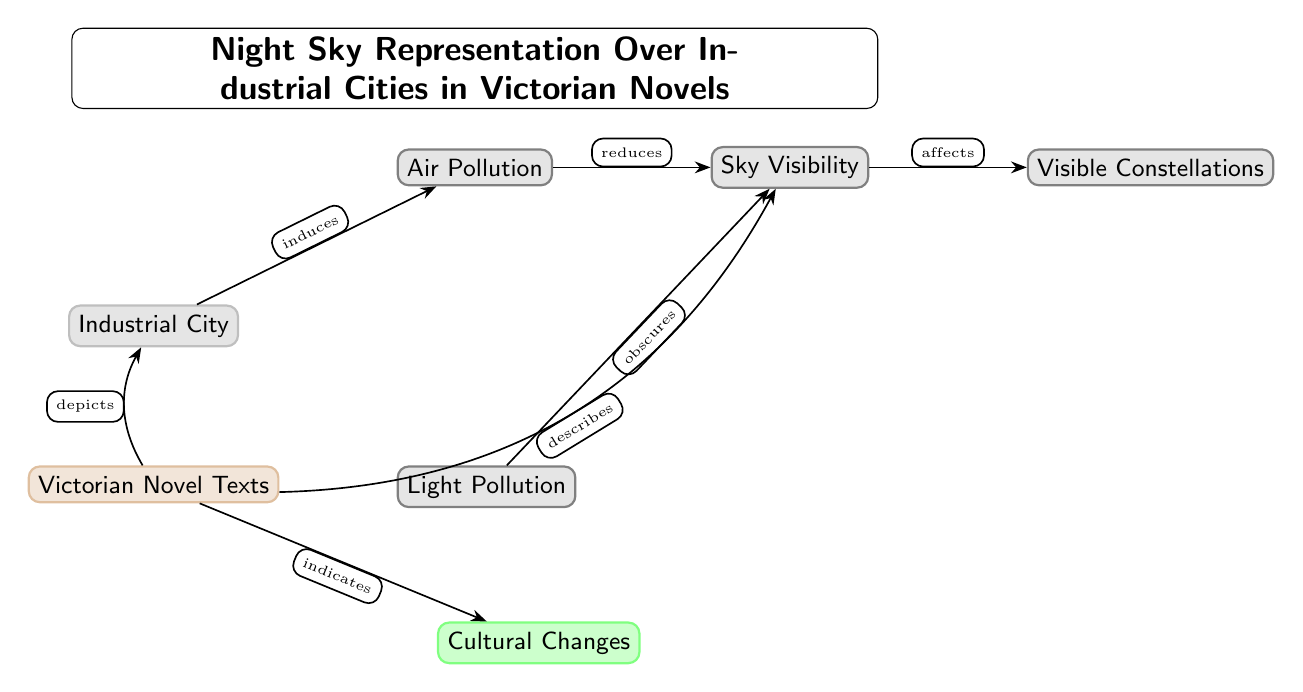What is the main depiction of the Victorian novels in the diagram? The main depiction of Victorian novels in the diagram is represented by the node labeled "Victorian Novel Texts". It is connected to the "Industrial City", indicating that the novels depict the industrial settings.
Answer: Victorian Novel Texts How many nodes are present in the diagram? By counting the nodes, we find there are six nodes: Industrial City, Air Pollution, Light Pollution, Sky Visibility, Visible Constellations, and Victorian Novel Texts.
Answer: 6 What effect does air pollution have on sky visibility? The diagram shows an edge labeled "reduces" connecting "Air Pollution" and "Sky Visibility". This indicates that air pollution negatively affects the ability to see the sky clearly.
Answer: reduces Which node is connected to "Visible Constellations"? The node "Sky Visibility" is directly connected to "Visible Constellations" with an edge labeled "affects", meaning that sky visibility influences the visibility of constellations in the night sky.
Answer: Sky Visibility What do the Victorian novels indicate about cultural changes? In the diagram, there is an edge labeled "indicates" connecting "Victorian Novel Texts" to "Cultural Changes". This means that the texts of Victorian novels reflect or suggest aspects of cultural changes.
Answer: Cultural Changes What type of pollution obscures sky visibility? The diagram shows "Light Pollution" as a node that connects to "Sky Visibility", with the edge labeled "obscures", clearly describing that light pollution blocks or dims the sky visibility.
Answer: Light Pollution How does the diagram illustrate the relationship between industrial cities and air pollution? The diagram shows an edge labeled "induces" connecting "Industrial City" to "Air Pollution", indicating that the existence of industrial cities leads to the presence of air pollution.
Answer: induces What connection does the diagram show between novels and sky visibility? The diagram displays a connection between "Victorian Novel Texts" and "Sky Visibility" with the edge labeled "describes", which signifies that the novels articulate or portray something about the state of sky visibility.
Answer: describes 